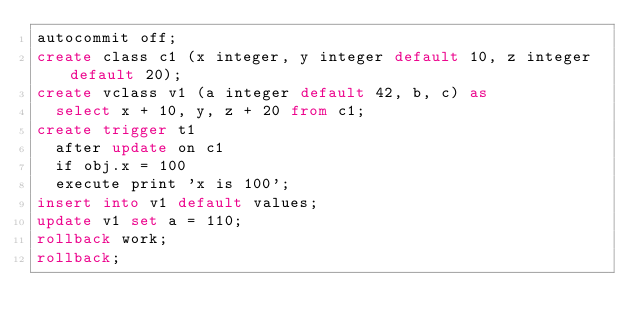<code> <loc_0><loc_0><loc_500><loc_500><_SQL_>autocommit off;
create class c1 (x integer, y integer default 10, z integer default 20);
create vclass v1 (a integer default 42, b, c) as 
  select x + 10, y, z + 20 from c1;
create trigger t1 
  after update on c1
  if obj.x = 100
  execute print 'x is 100';
insert into v1 default values;
update v1 set a = 110;
rollback work;
rollback;
</code> 